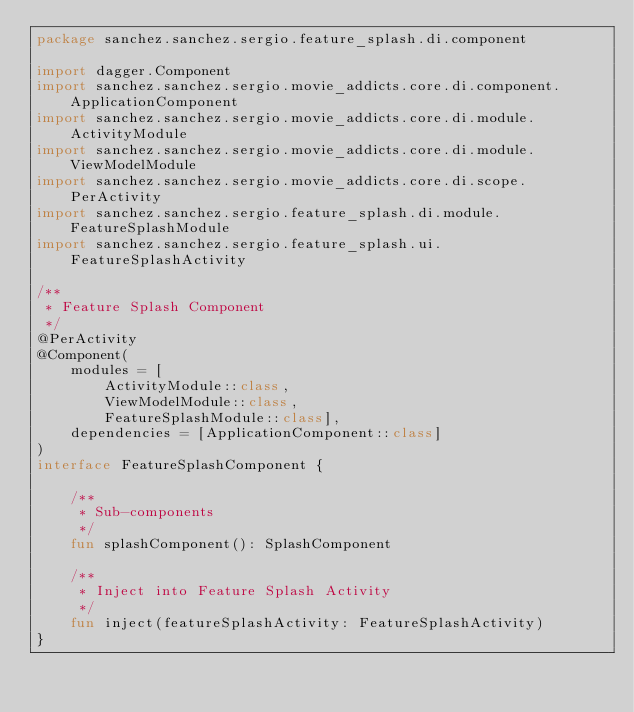Convert code to text. <code><loc_0><loc_0><loc_500><loc_500><_Kotlin_>package sanchez.sanchez.sergio.feature_splash.di.component

import dagger.Component
import sanchez.sanchez.sergio.movie_addicts.core.di.component.ApplicationComponent
import sanchez.sanchez.sergio.movie_addicts.core.di.module.ActivityModule
import sanchez.sanchez.sergio.movie_addicts.core.di.module.ViewModelModule
import sanchez.sanchez.sergio.movie_addicts.core.di.scope.PerActivity
import sanchez.sanchez.sergio.feature_splash.di.module.FeatureSplashModule
import sanchez.sanchez.sergio.feature_splash.ui.FeatureSplashActivity

/**
 * Feature Splash Component
 */
@PerActivity
@Component(
    modules = [
        ActivityModule::class,
        ViewModelModule::class,
        FeatureSplashModule::class],
    dependencies = [ApplicationComponent::class]
)
interface FeatureSplashComponent {

    /**
     * Sub-components
     */
    fun splashComponent(): SplashComponent

    /**
     * Inject into Feature Splash Activity
     */
    fun inject(featureSplashActivity: FeatureSplashActivity)
}</code> 